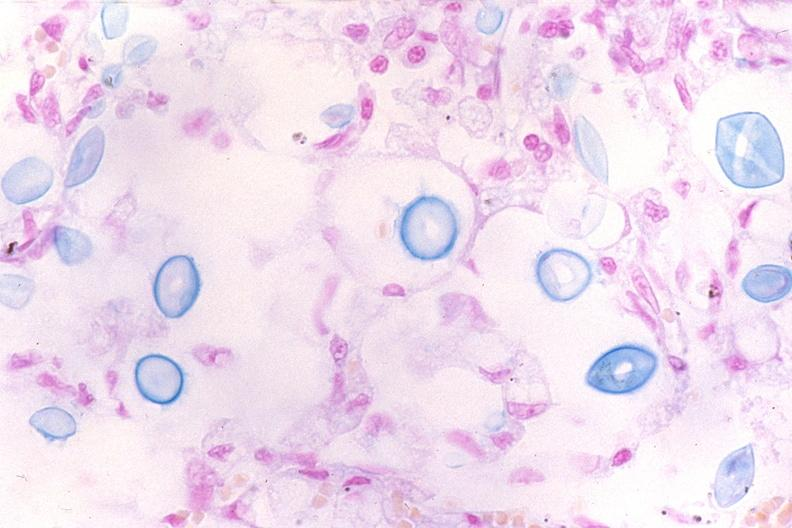what stain?
Answer the question using a single word or phrase. Mucicarmine 